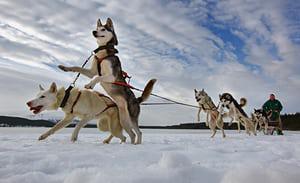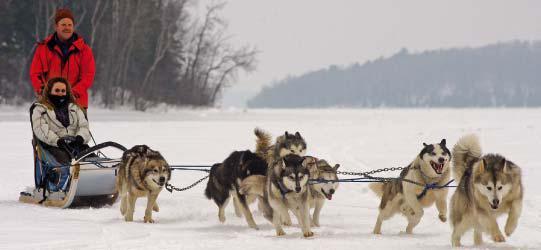The first image is the image on the left, the second image is the image on the right. Considering the images on both sides, is "In at least one image there are at least two people being pulled by at least 6 sled dogs." valid? Answer yes or no. Yes. The first image is the image on the left, the second image is the image on the right. Given the left and right images, does the statement "One of the people on the sleds is wearing a bright blue coat." hold true? Answer yes or no. No. 